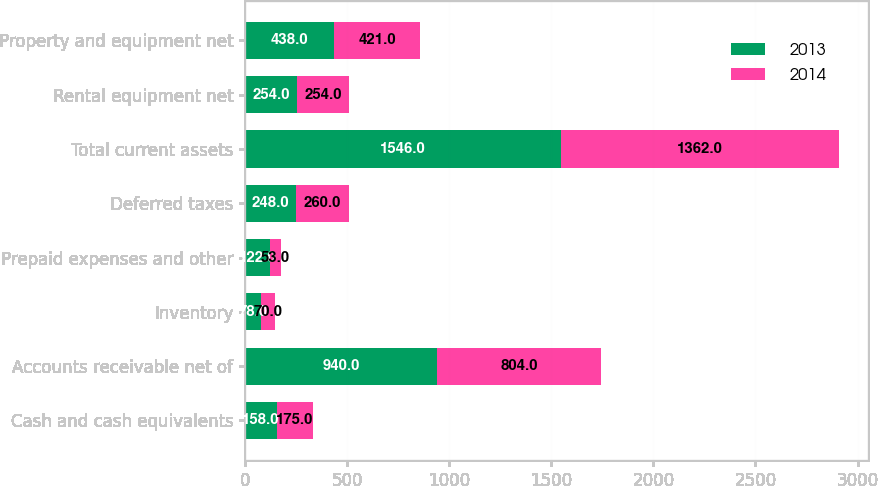Convert chart to OTSL. <chart><loc_0><loc_0><loc_500><loc_500><stacked_bar_chart><ecel><fcel>Cash and cash equivalents<fcel>Accounts receivable net of<fcel>Inventory<fcel>Prepaid expenses and other<fcel>Deferred taxes<fcel>Total current assets<fcel>Rental equipment net<fcel>Property and equipment net<nl><fcel>2013<fcel>158<fcel>940<fcel>78<fcel>122<fcel>248<fcel>1546<fcel>254<fcel>438<nl><fcel>2014<fcel>175<fcel>804<fcel>70<fcel>53<fcel>260<fcel>1362<fcel>254<fcel>421<nl></chart> 